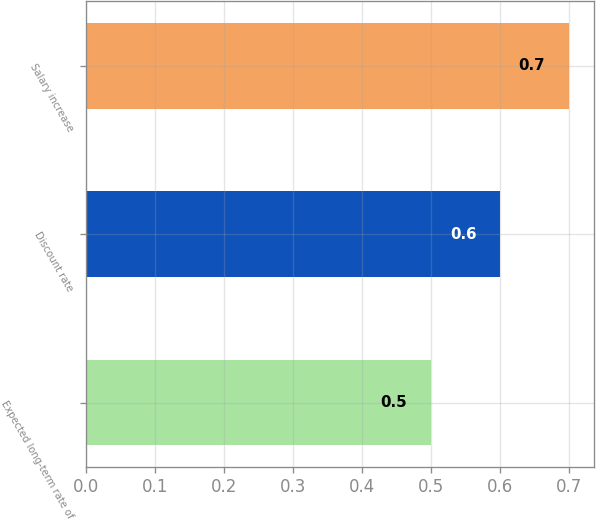<chart> <loc_0><loc_0><loc_500><loc_500><bar_chart><fcel>Expected long-term rate of<fcel>Discount rate<fcel>Salary increase<nl><fcel>0.5<fcel>0.6<fcel>0.7<nl></chart> 